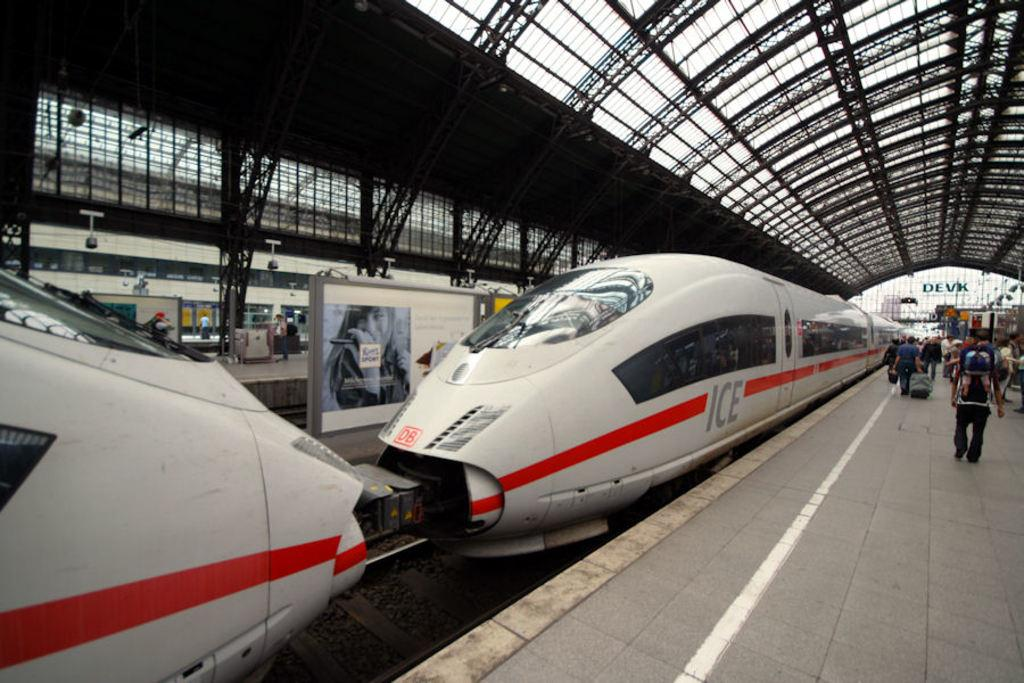<image>
Offer a succinct explanation of the picture presented. an electric train with the word ICE on it is waiting to be boarded 